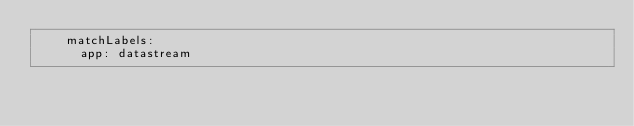Convert code to text. <code><loc_0><loc_0><loc_500><loc_500><_YAML_>    matchLabels:
      app: datastream</code> 